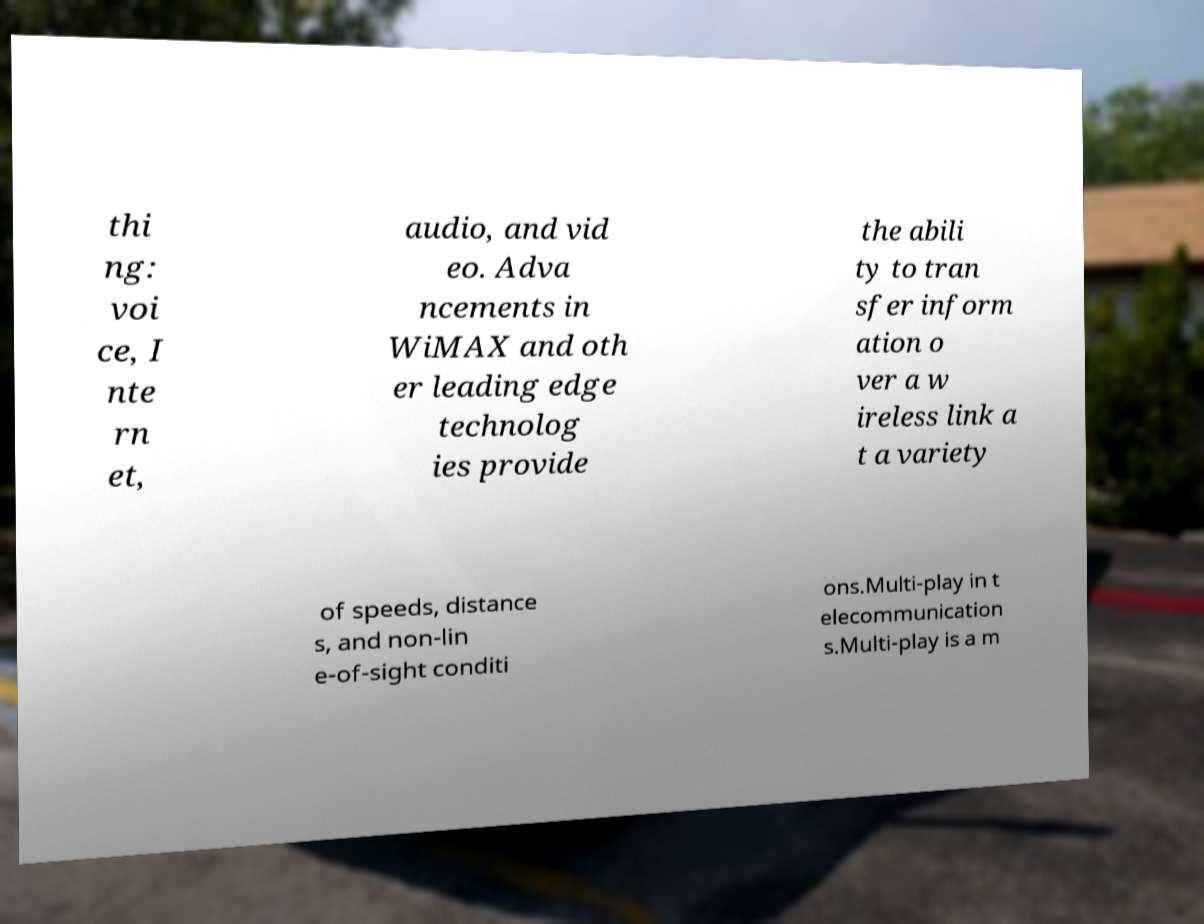What messages or text are displayed in this image? I need them in a readable, typed format. thi ng: voi ce, I nte rn et, audio, and vid eo. Adva ncements in WiMAX and oth er leading edge technolog ies provide the abili ty to tran sfer inform ation o ver a w ireless link a t a variety of speeds, distance s, and non-lin e-of-sight conditi ons.Multi-play in t elecommunication s.Multi-play is a m 